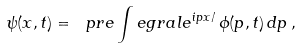<formula> <loc_0><loc_0><loc_500><loc_500>\psi ( x , t ) = \ p r e \int e g r a l e ^ { i p x / } \, \phi ( p , t ) \, d p \, ,</formula> 